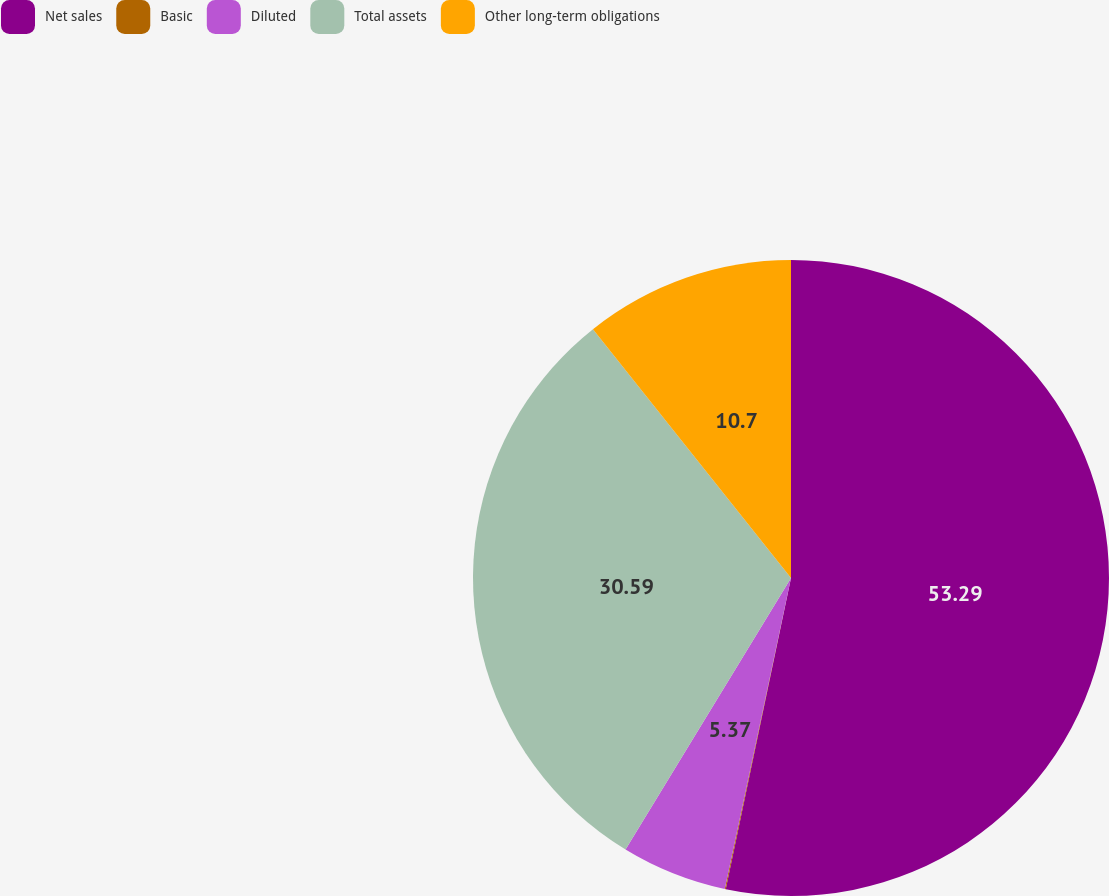Convert chart to OTSL. <chart><loc_0><loc_0><loc_500><loc_500><pie_chart><fcel>Net sales<fcel>Basic<fcel>Diluted<fcel>Total assets<fcel>Other long-term obligations<nl><fcel>53.29%<fcel>0.05%<fcel>5.37%<fcel>30.59%<fcel>10.7%<nl></chart> 